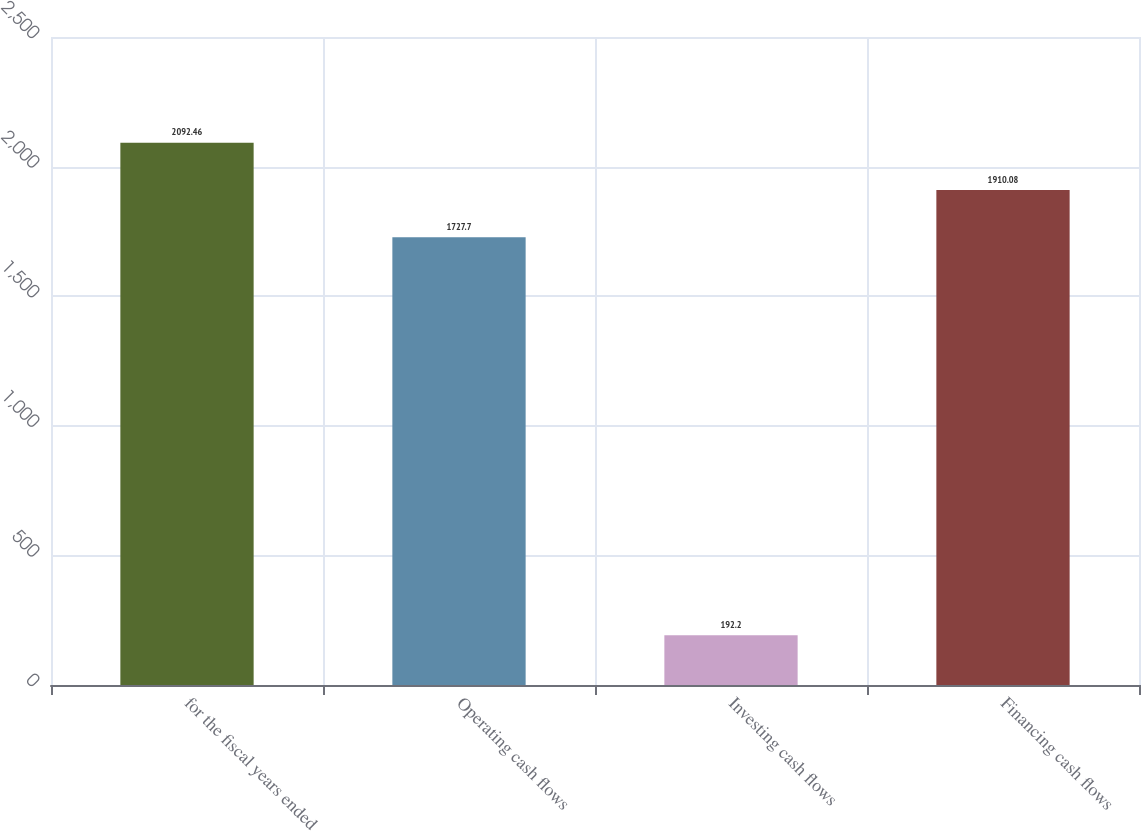Convert chart. <chart><loc_0><loc_0><loc_500><loc_500><bar_chart><fcel>for the fiscal years ended<fcel>Operating cash flows<fcel>Investing cash flows<fcel>Financing cash flows<nl><fcel>2092.46<fcel>1727.7<fcel>192.2<fcel>1910.08<nl></chart> 